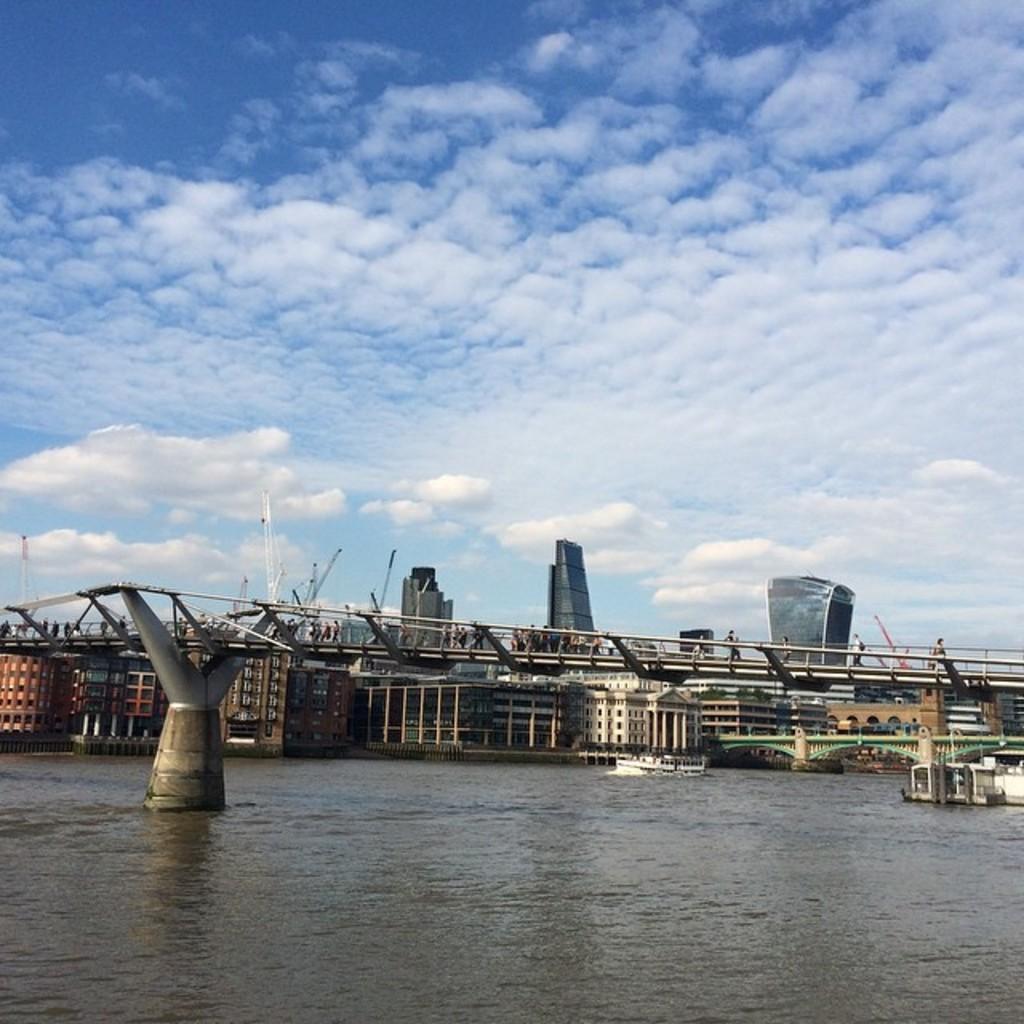Can you describe this image briefly? In this image I can see a boat on the water. I can see a bridge. In the background there are few buildings. At the top I can see clouds in the sky. 